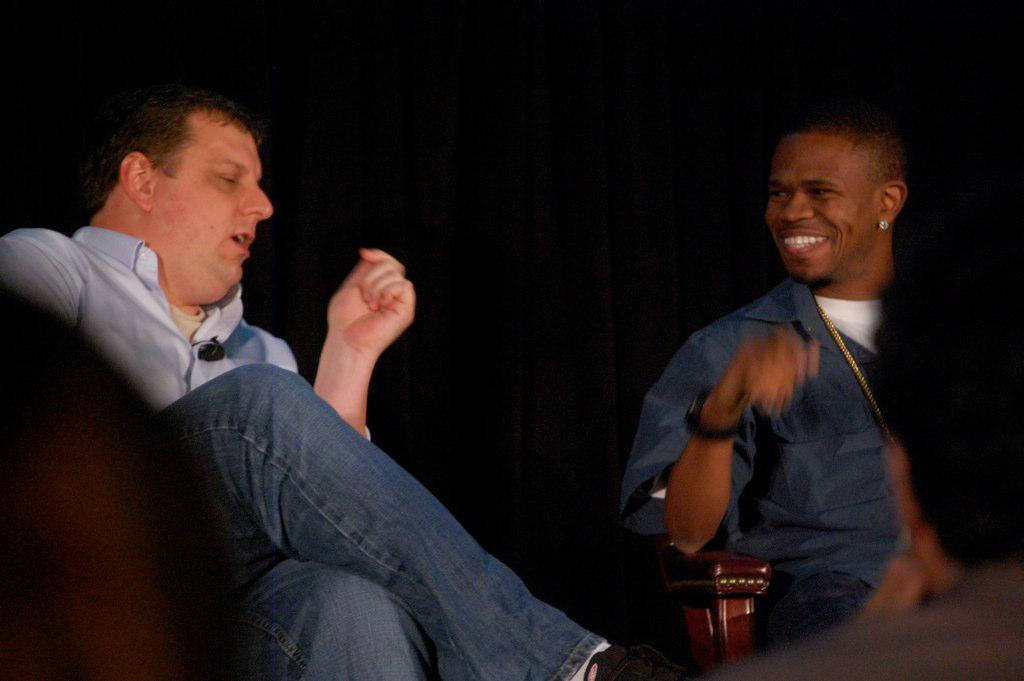What are the people in the image doing? There are people sitting on chairs in the image. What is the man in a shirt doing? The man in a shirt is explaining something. How does the other man appear in the image? Another man is smiling. What can be observed about the lighting in the image? The background of the image is dark. What type of stew is being served in the image? There is no stew present in the image. What authority figure can be seen in the image? There is no authority figure mentioned in the provided facts. 